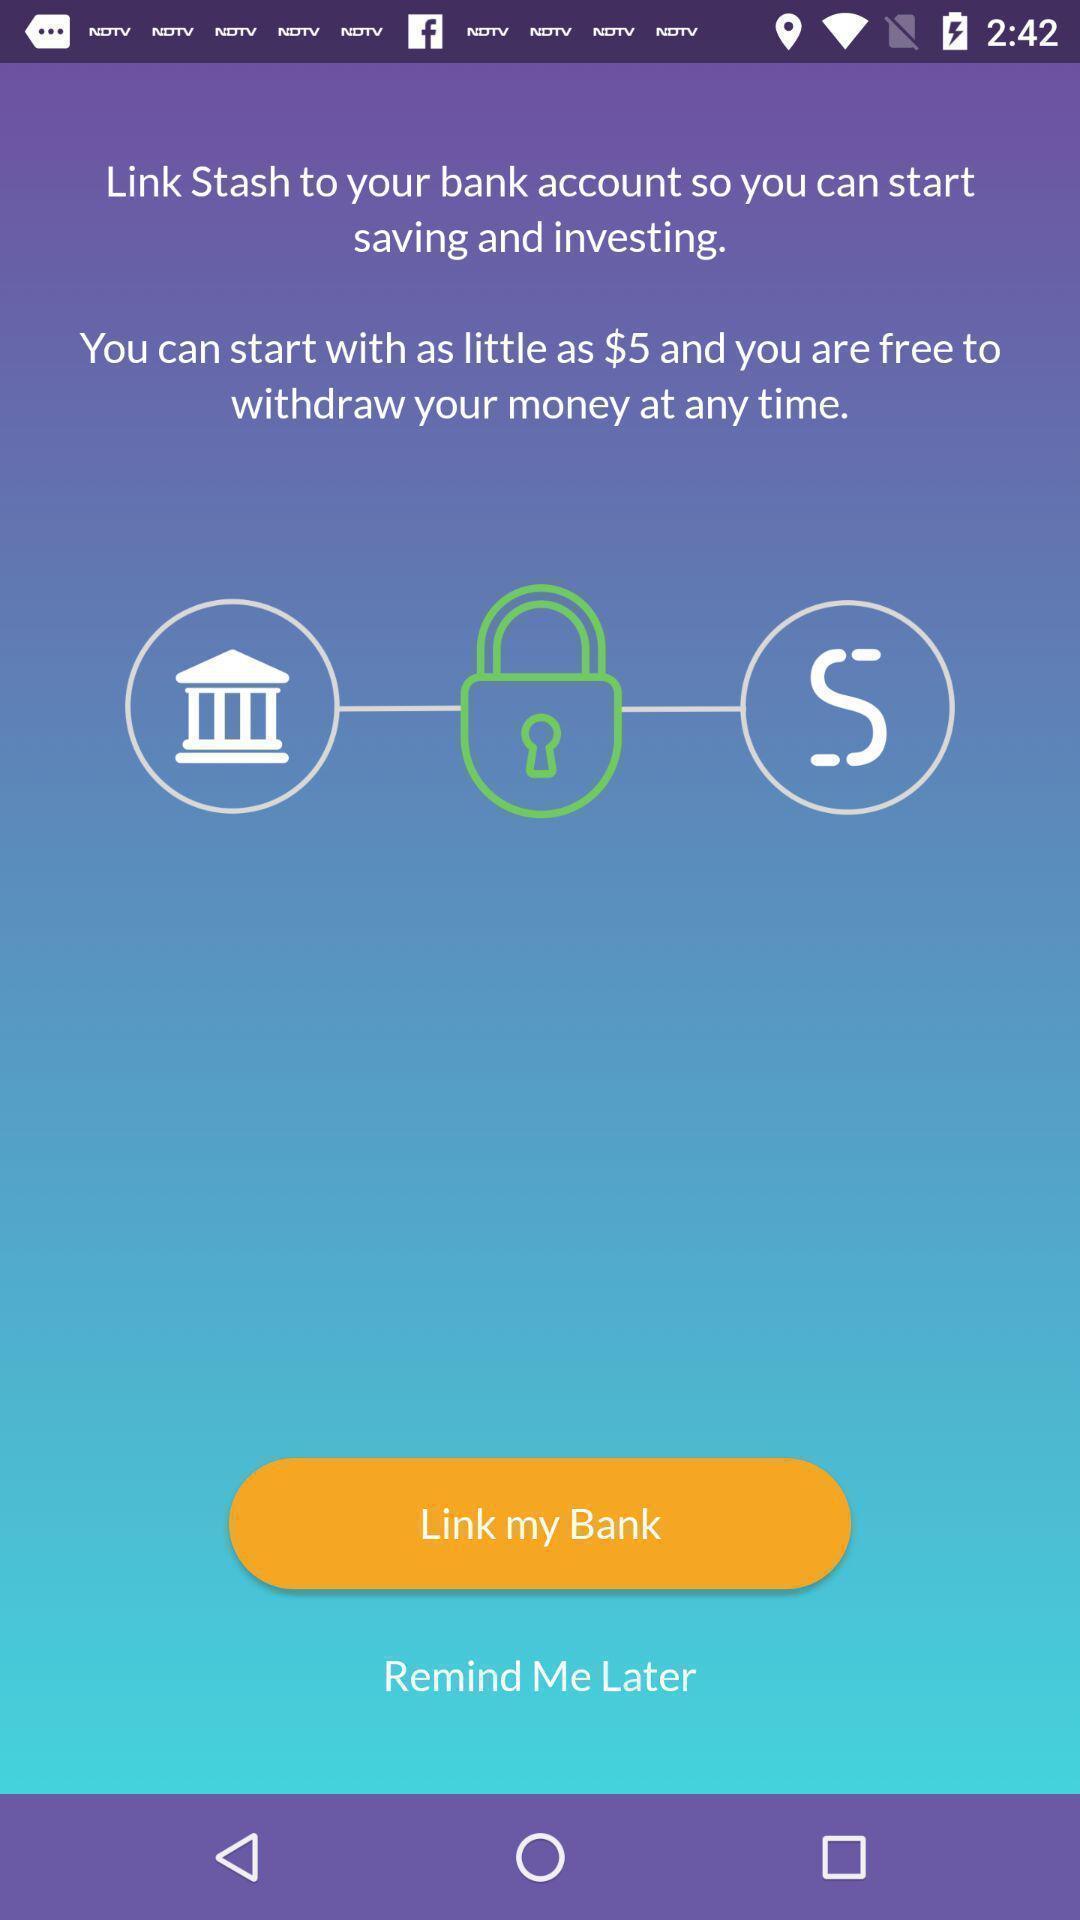Describe the visual elements of this screenshot. Screen displaying the instructions to link my bank. 